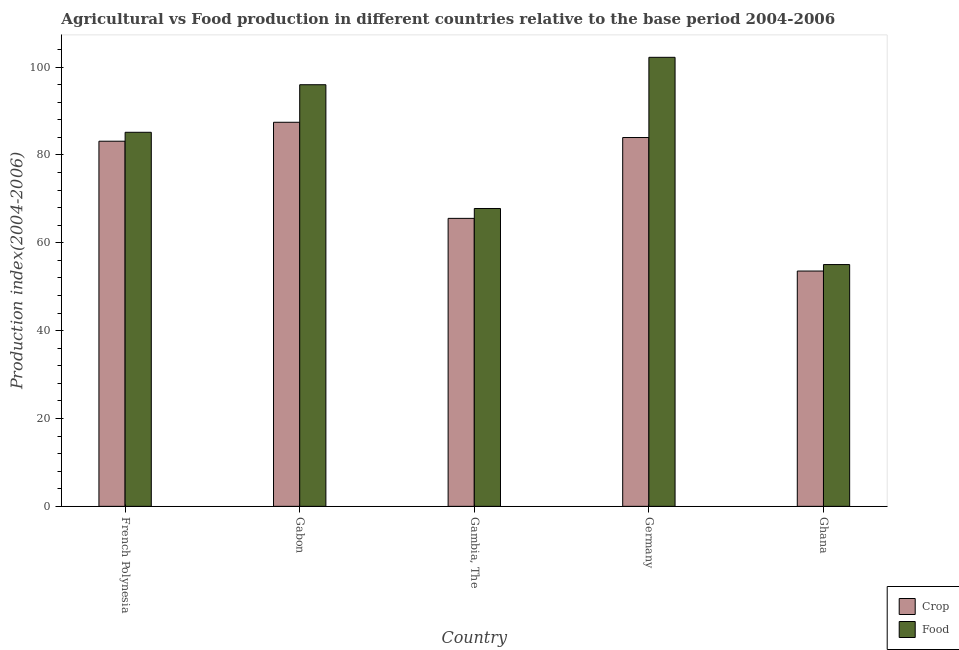How many groups of bars are there?
Your answer should be very brief. 5. Are the number of bars per tick equal to the number of legend labels?
Offer a very short reply. Yes. How many bars are there on the 4th tick from the left?
Provide a short and direct response. 2. What is the label of the 4th group of bars from the left?
Offer a very short reply. Germany. What is the crop production index in Germany?
Provide a short and direct response. 83.98. Across all countries, what is the maximum food production index?
Your answer should be very brief. 102.24. Across all countries, what is the minimum food production index?
Your answer should be very brief. 55.05. What is the total food production index in the graph?
Offer a very short reply. 406.28. What is the difference between the food production index in Gambia, The and that in Germany?
Keep it short and to the point. -34.42. What is the difference between the crop production index in French Polynesia and the food production index in Ghana?
Your answer should be compact. 28.09. What is the average food production index per country?
Make the answer very short. 81.26. What is the difference between the crop production index and food production index in Germany?
Your answer should be very brief. -18.26. What is the ratio of the food production index in Gabon to that in Germany?
Give a very brief answer. 0.94. Is the food production index in French Polynesia less than that in Gambia, The?
Make the answer very short. No. Is the difference between the crop production index in Gabon and Ghana greater than the difference between the food production index in Gabon and Ghana?
Ensure brevity in your answer.  No. What is the difference between the highest and the second highest crop production index?
Offer a terse response. 3.47. What is the difference between the highest and the lowest crop production index?
Keep it short and to the point. 33.87. In how many countries, is the food production index greater than the average food production index taken over all countries?
Provide a short and direct response. 3. What does the 1st bar from the left in French Polynesia represents?
Give a very brief answer. Crop. What does the 2nd bar from the right in French Polynesia represents?
Provide a succinct answer. Crop. Are all the bars in the graph horizontal?
Your response must be concise. No. Are the values on the major ticks of Y-axis written in scientific E-notation?
Provide a short and direct response. No. Does the graph contain any zero values?
Give a very brief answer. No. Where does the legend appear in the graph?
Ensure brevity in your answer.  Bottom right. How many legend labels are there?
Provide a short and direct response. 2. What is the title of the graph?
Provide a short and direct response. Agricultural vs Food production in different countries relative to the base period 2004-2006. Does "Infant" appear as one of the legend labels in the graph?
Keep it short and to the point. No. What is the label or title of the Y-axis?
Ensure brevity in your answer.  Production index(2004-2006). What is the Production index(2004-2006) of Crop in French Polynesia?
Give a very brief answer. 83.14. What is the Production index(2004-2006) in Food in French Polynesia?
Give a very brief answer. 85.17. What is the Production index(2004-2006) in Crop in Gabon?
Provide a short and direct response. 87.45. What is the Production index(2004-2006) in Food in Gabon?
Offer a very short reply. 96. What is the Production index(2004-2006) of Crop in Gambia, The?
Your response must be concise. 65.57. What is the Production index(2004-2006) of Food in Gambia, The?
Give a very brief answer. 67.82. What is the Production index(2004-2006) in Crop in Germany?
Give a very brief answer. 83.98. What is the Production index(2004-2006) of Food in Germany?
Keep it short and to the point. 102.24. What is the Production index(2004-2006) in Crop in Ghana?
Keep it short and to the point. 53.58. What is the Production index(2004-2006) in Food in Ghana?
Make the answer very short. 55.05. Across all countries, what is the maximum Production index(2004-2006) of Crop?
Your answer should be compact. 87.45. Across all countries, what is the maximum Production index(2004-2006) of Food?
Offer a terse response. 102.24. Across all countries, what is the minimum Production index(2004-2006) of Crop?
Provide a short and direct response. 53.58. Across all countries, what is the minimum Production index(2004-2006) in Food?
Provide a succinct answer. 55.05. What is the total Production index(2004-2006) of Crop in the graph?
Make the answer very short. 373.72. What is the total Production index(2004-2006) of Food in the graph?
Provide a succinct answer. 406.28. What is the difference between the Production index(2004-2006) in Crop in French Polynesia and that in Gabon?
Offer a terse response. -4.31. What is the difference between the Production index(2004-2006) of Food in French Polynesia and that in Gabon?
Offer a very short reply. -10.83. What is the difference between the Production index(2004-2006) in Crop in French Polynesia and that in Gambia, The?
Your response must be concise. 17.57. What is the difference between the Production index(2004-2006) in Food in French Polynesia and that in Gambia, The?
Your answer should be very brief. 17.35. What is the difference between the Production index(2004-2006) in Crop in French Polynesia and that in Germany?
Keep it short and to the point. -0.84. What is the difference between the Production index(2004-2006) in Food in French Polynesia and that in Germany?
Make the answer very short. -17.07. What is the difference between the Production index(2004-2006) in Crop in French Polynesia and that in Ghana?
Provide a short and direct response. 29.56. What is the difference between the Production index(2004-2006) in Food in French Polynesia and that in Ghana?
Offer a very short reply. 30.12. What is the difference between the Production index(2004-2006) in Crop in Gabon and that in Gambia, The?
Make the answer very short. 21.88. What is the difference between the Production index(2004-2006) in Food in Gabon and that in Gambia, The?
Your response must be concise. 28.18. What is the difference between the Production index(2004-2006) in Crop in Gabon and that in Germany?
Provide a short and direct response. 3.47. What is the difference between the Production index(2004-2006) of Food in Gabon and that in Germany?
Make the answer very short. -6.24. What is the difference between the Production index(2004-2006) of Crop in Gabon and that in Ghana?
Give a very brief answer. 33.87. What is the difference between the Production index(2004-2006) in Food in Gabon and that in Ghana?
Your response must be concise. 40.95. What is the difference between the Production index(2004-2006) of Crop in Gambia, The and that in Germany?
Provide a short and direct response. -18.41. What is the difference between the Production index(2004-2006) in Food in Gambia, The and that in Germany?
Your answer should be compact. -34.42. What is the difference between the Production index(2004-2006) in Crop in Gambia, The and that in Ghana?
Provide a succinct answer. 11.99. What is the difference between the Production index(2004-2006) of Food in Gambia, The and that in Ghana?
Provide a succinct answer. 12.77. What is the difference between the Production index(2004-2006) of Crop in Germany and that in Ghana?
Your response must be concise. 30.4. What is the difference between the Production index(2004-2006) of Food in Germany and that in Ghana?
Your response must be concise. 47.19. What is the difference between the Production index(2004-2006) in Crop in French Polynesia and the Production index(2004-2006) in Food in Gabon?
Keep it short and to the point. -12.86. What is the difference between the Production index(2004-2006) of Crop in French Polynesia and the Production index(2004-2006) of Food in Gambia, The?
Make the answer very short. 15.32. What is the difference between the Production index(2004-2006) of Crop in French Polynesia and the Production index(2004-2006) of Food in Germany?
Provide a succinct answer. -19.1. What is the difference between the Production index(2004-2006) of Crop in French Polynesia and the Production index(2004-2006) of Food in Ghana?
Offer a very short reply. 28.09. What is the difference between the Production index(2004-2006) in Crop in Gabon and the Production index(2004-2006) in Food in Gambia, The?
Offer a terse response. 19.63. What is the difference between the Production index(2004-2006) in Crop in Gabon and the Production index(2004-2006) in Food in Germany?
Keep it short and to the point. -14.79. What is the difference between the Production index(2004-2006) of Crop in Gabon and the Production index(2004-2006) of Food in Ghana?
Ensure brevity in your answer.  32.4. What is the difference between the Production index(2004-2006) in Crop in Gambia, The and the Production index(2004-2006) in Food in Germany?
Ensure brevity in your answer.  -36.67. What is the difference between the Production index(2004-2006) in Crop in Gambia, The and the Production index(2004-2006) in Food in Ghana?
Offer a terse response. 10.52. What is the difference between the Production index(2004-2006) of Crop in Germany and the Production index(2004-2006) of Food in Ghana?
Your answer should be very brief. 28.93. What is the average Production index(2004-2006) of Crop per country?
Ensure brevity in your answer.  74.74. What is the average Production index(2004-2006) in Food per country?
Your response must be concise. 81.26. What is the difference between the Production index(2004-2006) of Crop and Production index(2004-2006) of Food in French Polynesia?
Provide a succinct answer. -2.03. What is the difference between the Production index(2004-2006) in Crop and Production index(2004-2006) in Food in Gabon?
Provide a short and direct response. -8.55. What is the difference between the Production index(2004-2006) of Crop and Production index(2004-2006) of Food in Gambia, The?
Make the answer very short. -2.25. What is the difference between the Production index(2004-2006) in Crop and Production index(2004-2006) in Food in Germany?
Offer a very short reply. -18.26. What is the difference between the Production index(2004-2006) in Crop and Production index(2004-2006) in Food in Ghana?
Offer a very short reply. -1.47. What is the ratio of the Production index(2004-2006) in Crop in French Polynesia to that in Gabon?
Offer a very short reply. 0.95. What is the ratio of the Production index(2004-2006) of Food in French Polynesia to that in Gabon?
Your response must be concise. 0.89. What is the ratio of the Production index(2004-2006) in Crop in French Polynesia to that in Gambia, The?
Offer a very short reply. 1.27. What is the ratio of the Production index(2004-2006) in Food in French Polynesia to that in Gambia, The?
Keep it short and to the point. 1.26. What is the ratio of the Production index(2004-2006) in Food in French Polynesia to that in Germany?
Offer a very short reply. 0.83. What is the ratio of the Production index(2004-2006) in Crop in French Polynesia to that in Ghana?
Your answer should be very brief. 1.55. What is the ratio of the Production index(2004-2006) of Food in French Polynesia to that in Ghana?
Your answer should be compact. 1.55. What is the ratio of the Production index(2004-2006) of Crop in Gabon to that in Gambia, The?
Ensure brevity in your answer.  1.33. What is the ratio of the Production index(2004-2006) in Food in Gabon to that in Gambia, The?
Your answer should be very brief. 1.42. What is the ratio of the Production index(2004-2006) of Crop in Gabon to that in Germany?
Your answer should be compact. 1.04. What is the ratio of the Production index(2004-2006) of Food in Gabon to that in Germany?
Offer a very short reply. 0.94. What is the ratio of the Production index(2004-2006) of Crop in Gabon to that in Ghana?
Your response must be concise. 1.63. What is the ratio of the Production index(2004-2006) in Food in Gabon to that in Ghana?
Provide a short and direct response. 1.74. What is the ratio of the Production index(2004-2006) in Crop in Gambia, The to that in Germany?
Provide a succinct answer. 0.78. What is the ratio of the Production index(2004-2006) in Food in Gambia, The to that in Germany?
Make the answer very short. 0.66. What is the ratio of the Production index(2004-2006) in Crop in Gambia, The to that in Ghana?
Offer a terse response. 1.22. What is the ratio of the Production index(2004-2006) of Food in Gambia, The to that in Ghana?
Offer a terse response. 1.23. What is the ratio of the Production index(2004-2006) in Crop in Germany to that in Ghana?
Offer a terse response. 1.57. What is the ratio of the Production index(2004-2006) in Food in Germany to that in Ghana?
Your answer should be compact. 1.86. What is the difference between the highest and the second highest Production index(2004-2006) of Crop?
Your answer should be very brief. 3.47. What is the difference between the highest and the second highest Production index(2004-2006) in Food?
Your answer should be compact. 6.24. What is the difference between the highest and the lowest Production index(2004-2006) in Crop?
Make the answer very short. 33.87. What is the difference between the highest and the lowest Production index(2004-2006) in Food?
Make the answer very short. 47.19. 